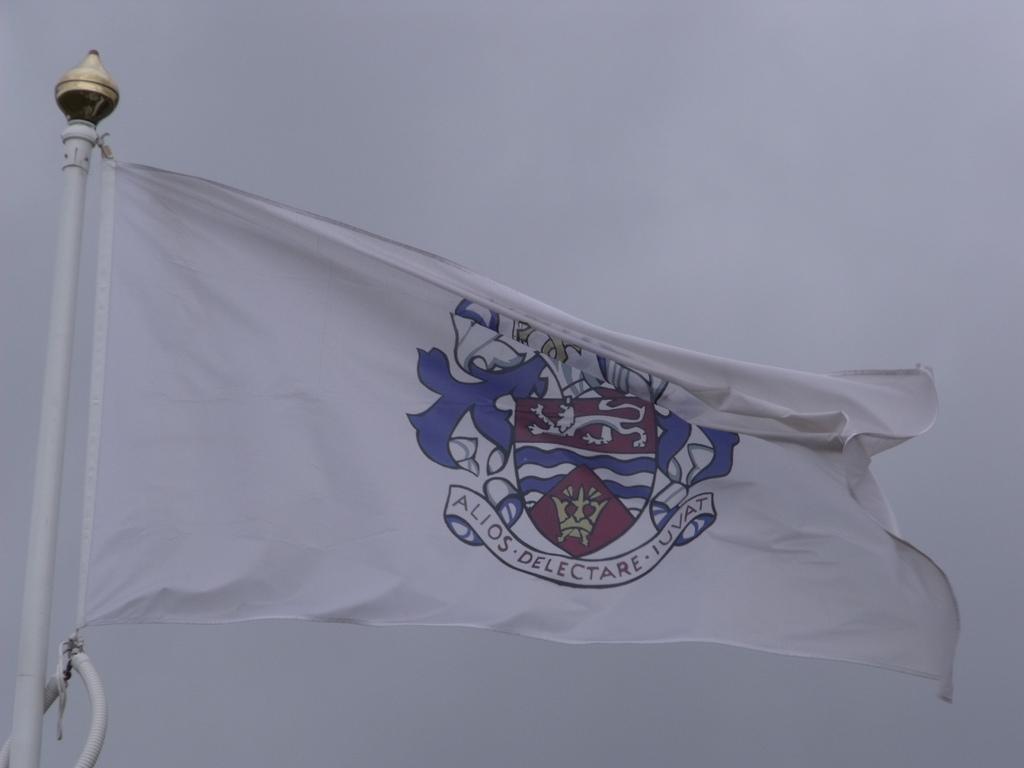Please provide a concise description of this image. In the foreground of this picture, there is a flag and in the background there is the sky. 